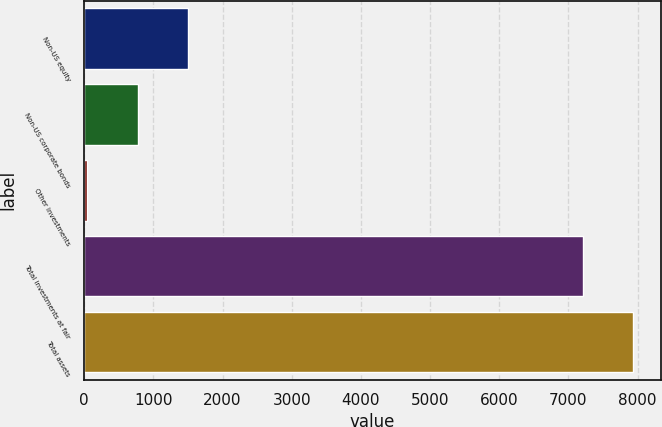Convert chart to OTSL. <chart><loc_0><loc_0><loc_500><loc_500><bar_chart><fcel>Non-US equity<fcel>Non-US corporate bonds<fcel>Other investments<fcel>Total investments at fair<fcel>Total assets<nl><fcel>1500.2<fcel>772.6<fcel>45<fcel>7210<fcel>7937.6<nl></chart> 